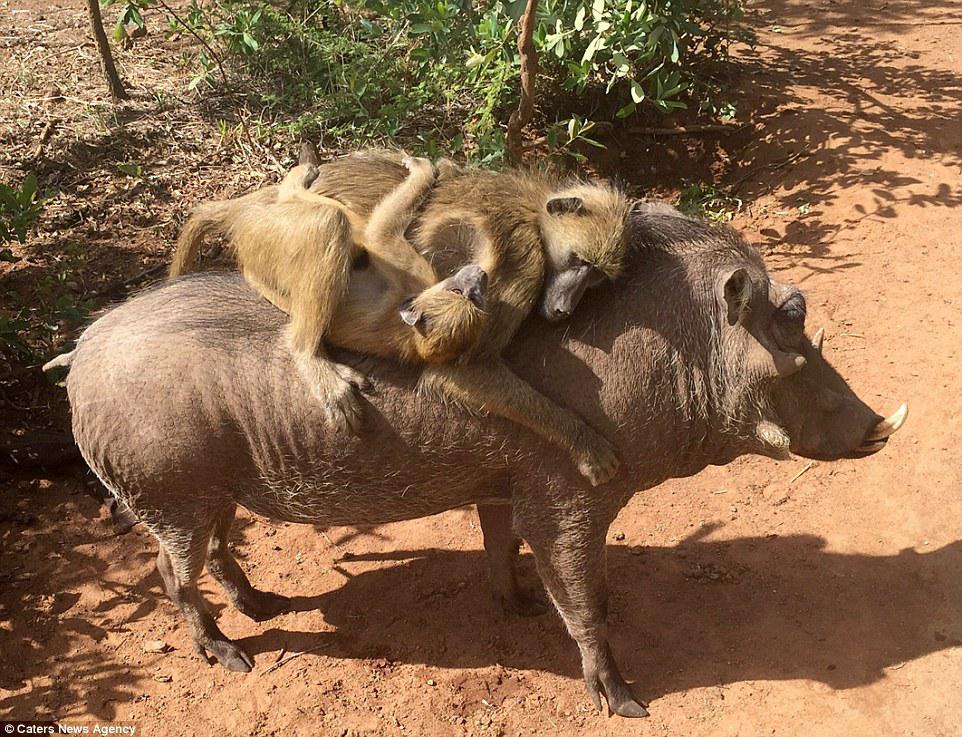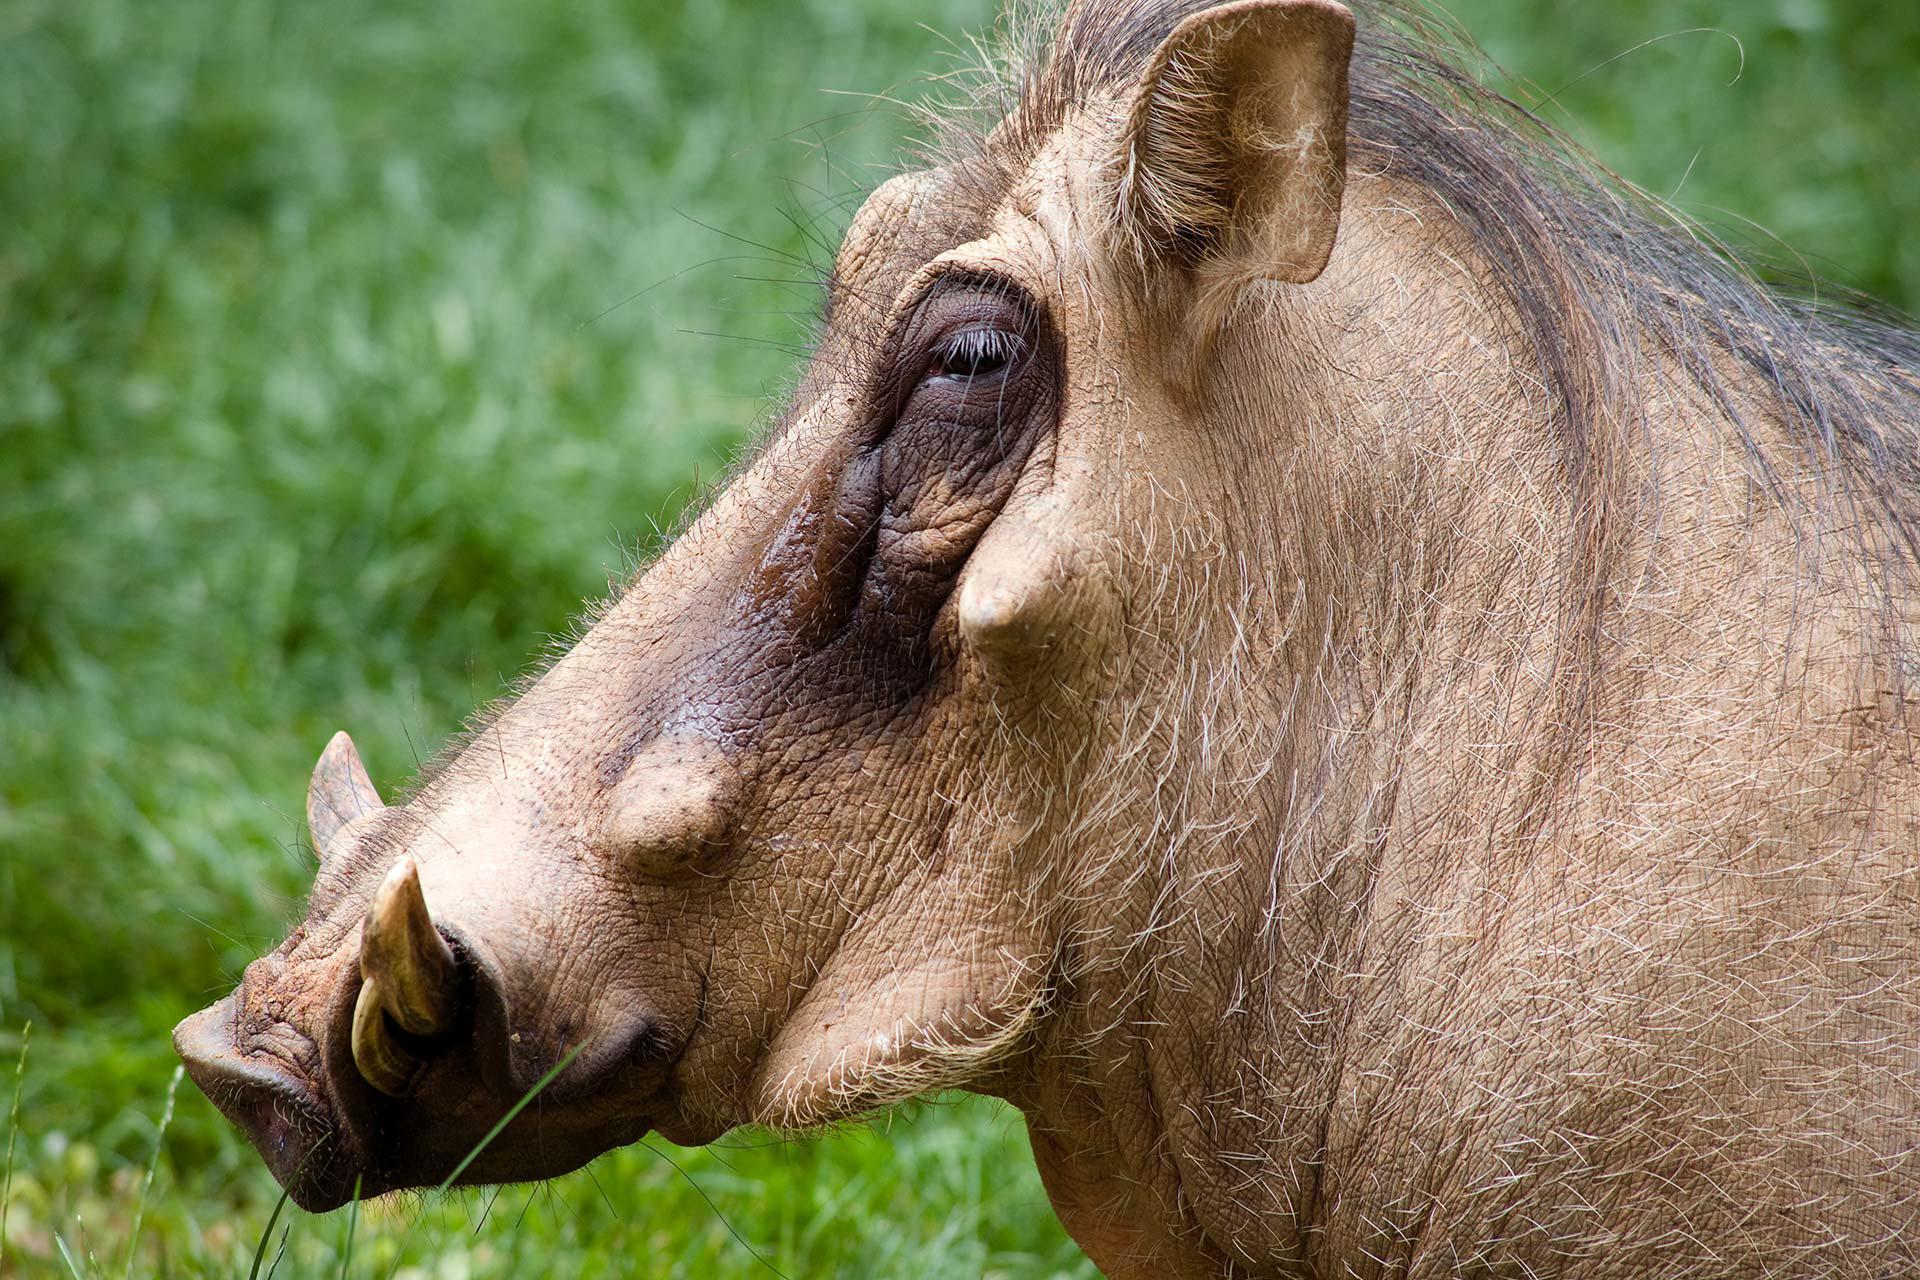The first image is the image on the left, the second image is the image on the right. Analyze the images presented: Is the assertion "A total of two animals are shown in a natural setting." valid? Answer yes or no. No. The first image is the image on the left, the second image is the image on the right. For the images shown, is this caption "Three animals, including an adult warthog, are in the left image." true? Answer yes or no. Yes. 